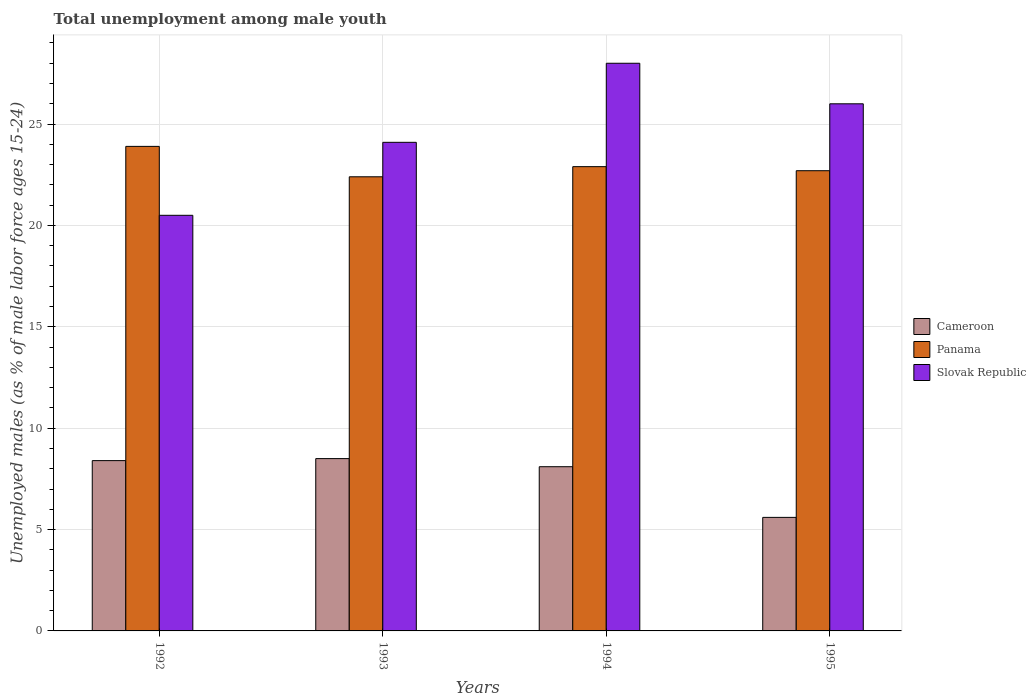How many different coloured bars are there?
Give a very brief answer. 3. How many groups of bars are there?
Give a very brief answer. 4. Are the number of bars per tick equal to the number of legend labels?
Offer a terse response. Yes. What is the label of the 1st group of bars from the left?
Give a very brief answer. 1992. What is the percentage of unemployed males in in Slovak Republic in 1992?
Ensure brevity in your answer.  20.5. Across all years, what is the maximum percentage of unemployed males in in Cameroon?
Provide a succinct answer. 8.5. Across all years, what is the minimum percentage of unemployed males in in Slovak Republic?
Your answer should be compact. 20.5. In which year was the percentage of unemployed males in in Cameroon maximum?
Your response must be concise. 1993. In which year was the percentage of unemployed males in in Cameroon minimum?
Offer a very short reply. 1995. What is the total percentage of unemployed males in in Panama in the graph?
Your answer should be compact. 91.9. What is the difference between the percentage of unemployed males in in Cameroon in 1992 and that in 1993?
Provide a succinct answer. -0.1. What is the difference between the percentage of unemployed males in in Cameroon in 1994 and the percentage of unemployed males in in Panama in 1995?
Make the answer very short. -14.6. What is the average percentage of unemployed males in in Slovak Republic per year?
Ensure brevity in your answer.  24.65. In the year 1992, what is the difference between the percentage of unemployed males in in Panama and percentage of unemployed males in in Cameroon?
Ensure brevity in your answer.  15.5. What is the ratio of the percentage of unemployed males in in Panama in 1992 to that in 1995?
Make the answer very short. 1.05. Is the percentage of unemployed males in in Slovak Republic in 1992 less than that in 1993?
Keep it short and to the point. Yes. What is the difference between the highest and the second highest percentage of unemployed males in in Slovak Republic?
Offer a very short reply. 2. In how many years, is the percentage of unemployed males in in Panama greater than the average percentage of unemployed males in in Panama taken over all years?
Provide a succinct answer. 1. What does the 2nd bar from the left in 1995 represents?
Your answer should be very brief. Panama. What does the 2nd bar from the right in 1995 represents?
Keep it short and to the point. Panama. Are all the bars in the graph horizontal?
Make the answer very short. No. How many years are there in the graph?
Your response must be concise. 4. What is the difference between two consecutive major ticks on the Y-axis?
Your answer should be compact. 5. Are the values on the major ticks of Y-axis written in scientific E-notation?
Give a very brief answer. No. Does the graph contain any zero values?
Your answer should be very brief. No. Does the graph contain grids?
Your response must be concise. Yes. How many legend labels are there?
Provide a succinct answer. 3. What is the title of the graph?
Offer a very short reply. Total unemployment among male youth. What is the label or title of the Y-axis?
Your response must be concise. Unemployed males (as % of male labor force ages 15-24). What is the Unemployed males (as % of male labor force ages 15-24) in Cameroon in 1992?
Keep it short and to the point. 8.4. What is the Unemployed males (as % of male labor force ages 15-24) in Panama in 1992?
Offer a terse response. 23.9. What is the Unemployed males (as % of male labor force ages 15-24) of Cameroon in 1993?
Provide a succinct answer. 8.5. What is the Unemployed males (as % of male labor force ages 15-24) in Panama in 1993?
Ensure brevity in your answer.  22.4. What is the Unemployed males (as % of male labor force ages 15-24) in Slovak Republic in 1993?
Offer a very short reply. 24.1. What is the Unemployed males (as % of male labor force ages 15-24) of Cameroon in 1994?
Provide a succinct answer. 8.1. What is the Unemployed males (as % of male labor force ages 15-24) in Panama in 1994?
Make the answer very short. 22.9. What is the Unemployed males (as % of male labor force ages 15-24) of Slovak Republic in 1994?
Your response must be concise. 28. What is the Unemployed males (as % of male labor force ages 15-24) in Cameroon in 1995?
Your answer should be very brief. 5.6. What is the Unemployed males (as % of male labor force ages 15-24) in Panama in 1995?
Provide a short and direct response. 22.7. What is the Unemployed males (as % of male labor force ages 15-24) in Slovak Republic in 1995?
Offer a very short reply. 26. Across all years, what is the maximum Unemployed males (as % of male labor force ages 15-24) in Panama?
Keep it short and to the point. 23.9. Across all years, what is the maximum Unemployed males (as % of male labor force ages 15-24) in Slovak Republic?
Your response must be concise. 28. Across all years, what is the minimum Unemployed males (as % of male labor force ages 15-24) of Cameroon?
Make the answer very short. 5.6. Across all years, what is the minimum Unemployed males (as % of male labor force ages 15-24) of Panama?
Your answer should be very brief. 22.4. Across all years, what is the minimum Unemployed males (as % of male labor force ages 15-24) in Slovak Republic?
Provide a succinct answer. 20.5. What is the total Unemployed males (as % of male labor force ages 15-24) of Cameroon in the graph?
Make the answer very short. 30.6. What is the total Unemployed males (as % of male labor force ages 15-24) of Panama in the graph?
Offer a terse response. 91.9. What is the total Unemployed males (as % of male labor force ages 15-24) in Slovak Republic in the graph?
Keep it short and to the point. 98.6. What is the difference between the Unemployed males (as % of male labor force ages 15-24) of Cameroon in 1992 and that in 1993?
Offer a terse response. -0.1. What is the difference between the Unemployed males (as % of male labor force ages 15-24) in Panama in 1992 and that in 1993?
Provide a short and direct response. 1.5. What is the difference between the Unemployed males (as % of male labor force ages 15-24) of Cameroon in 1992 and that in 1994?
Keep it short and to the point. 0.3. What is the difference between the Unemployed males (as % of male labor force ages 15-24) in Slovak Republic in 1992 and that in 1994?
Your answer should be compact. -7.5. What is the difference between the Unemployed males (as % of male labor force ages 15-24) in Cameroon in 1992 and that in 1995?
Your answer should be compact. 2.8. What is the difference between the Unemployed males (as % of male labor force ages 15-24) in Panama in 1992 and that in 1995?
Provide a succinct answer. 1.2. What is the difference between the Unemployed males (as % of male labor force ages 15-24) in Slovak Republic in 1992 and that in 1995?
Give a very brief answer. -5.5. What is the difference between the Unemployed males (as % of male labor force ages 15-24) in Cameroon in 1993 and that in 1994?
Ensure brevity in your answer.  0.4. What is the difference between the Unemployed males (as % of male labor force ages 15-24) in Cameroon in 1993 and that in 1995?
Keep it short and to the point. 2.9. What is the difference between the Unemployed males (as % of male labor force ages 15-24) in Slovak Republic in 1993 and that in 1995?
Give a very brief answer. -1.9. What is the difference between the Unemployed males (as % of male labor force ages 15-24) of Panama in 1994 and that in 1995?
Make the answer very short. 0.2. What is the difference between the Unemployed males (as % of male labor force ages 15-24) in Slovak Republic in 1994 and that in 1995?
Keep it short and to the point. 2. What is the difference between the Unemployed males (as % of male labor force ages 15-24) of Cameroon in 1992 and the Unemployed males (as % of male labor force ages 15-24) of Panama in 1993?
Your answer should be compact. -14. What is the difference between the Unemployed males (as % of male labor force ages 15-24) of Cameroon in 1992 and the Unemployed males (as % of male labor force ages 15-24) of Slovak Republic in 1993?
Make the answer very short. -15.7. What is the difference between the Unemployed males (as % of male labor force ages 15-24) in Panama in 1992 and the Unemployed males (as % of male labor force ages 15-24) in Slovak Republic in 1993?
Your response must be concise. -0.2. What is the difference between the Unemployed males (as % of male labor force ages 15-24) in Cameroon in 1992 and the Unemployed males (as % of male labor force ages 15-24) in Panama in 1994?
Your response must be concise. -14.5. What is the difference between the Unemployed males (as % of male labor force ages 15-24) in Cameroon in 1992 and the Unemployed males (as % of male labor force ages 15-24) in Slovak Republic in 1994?
Offer a terse response. -19.6. What is the difference between the Unemployed males (as % of male labor force ages 15-24) in Cameroon in 1992 and the Unemployed males (as % of male labor force ages 15-24) in Panama in 1995?
Ensure brevity in your answer.  -14.3. What is the difference between the Unemployed males (as % of male labor force ages 15-24) in Cameroon in 1992 and the Unemployed males (as % of male labor force ages 15-24) in Slovak Republic in 1995?
Your answer should be very brief. -17.6. What is the difference between the Unemployed males (as % of male labor force ages 15-24) in Cameroon in 1993 and the Unemployed males (as % of male labor force ages 15-24) in Panama in 1994?
Provide a succinct answer. -14.4. What is the difference between the Unemployed males (as % of male labor force ages 15-24) in Cameroon in 1993 and the Unemployed males (as % of male labor force ages 15-24) in Slovak Republic in 1994?
Keep it short and to the point. -19.5. What is the difference between the Unemployed males (as % of male labor force ages 15-24) in Panama in 1993 and the Unemployed males (as % of male labor force ages 15-24) in Slovak Republic in 1994?
Your answer should be very brief. -5.6. What is the difference between the Unemployed males (as % of male labor force ages 15-24) of Cameroon in 1993 and the Unemployed males (as % of male labor force ages 15-24) of Slovak Republic in 1995?
Offer a very short reply. -17.5. What is the difference between the Unemployed males (as % of male labor force ages 15-24) of Panama in 1993 and the Unemployed males (as % of male labor force ages 15-24) of Slovak Republic in 1995?
Provide a short and direct response. -3.6. What is the difference between the Unemployed males (as % of male labor force ages 15-24) of Cameroon in 1994 and the Unemployed males (as % of male labor force ages 15-24) of Panama in 1995?
Make the answer very short. -14.6. What is the difference between the Unemployed males (as % of male labor force ages 15-24) of Cameroon in 1994 and the Unemployed males (as % of male labor force ages 15-24) of Slovak Republic in 1995?
Offer a terse response. -17.9. What is the average Unemployed males (as % of male labor force ages 15-24) of Cameroon per year?
Offer a terse response. 7.65. What is the average Unemployed males (as % of male labor force ages 15-24) in Panama per year?
Make the answer very short. 22.98. What is the average Unemployed males (as % of male labor force ages 15-24) of Slovak Republic per year?
Keep it short and to the point. 24.65. In the year 1992, what is the difference between the Unemployed males (as % of male labor force ages 15-24) in Cameroon and Unemployed males (as % of male labor force ages 15-24) in Panama?
Provide a succinct answer. -15.5. In the year 1993, what is the difference between the Unemployed males (as % of male labor force ages 15-24) of Cameroon and Unemployed males (as % of male labor force ages 15-24) of Slovak Republic?
Keep it short and to the point. -15.6. In the year 1993, what is the difference between the Unemployed males (as % of male labor force ages 15-24) of Panama and Unemployed males (as % of male labor force ages 15-24) of Slovak Republic?
Your response must be concise. -1.7. In the year 1994, what is the difference between the Unemployed males (as % of male labor force ages 15-24) of Cameroon and Unemployed males (as % of male labor force ages 15-24) of Panama?
Offer a terse response. -14.8. In the year 1994, what is the difference between the Unemployed males (as % of male labor force ages 15-24) in Cameroon and Unemployed males (as % of male labor force ages 15-24) in Slovak Republic?
Your answer should be compact. -19.9. In the year 1995, what is the difference between the Unemployed males (as % of male labor force ages 15-24) of Cameroon and Unemployed males (as % of male labor force ages 15-24) of Panama?
Offer a very short reply. -17.1. In the year 1995, what is the difference between the Unemployed males (as % of male labor force ages 15-24) in Cameroon and Unemployed males (as % of male labor force ages 15-24) in Slovak Republic?
Provide a succinct answer. -20.4. What is the ratio of the Unemployed males (as % of male labor force ages 15-24) of Cameroon in 1992 to that in 1993?
Give a very brief answer. 0.99. What is the ratio of the Unemployed males (as % of male labor force ages 15-24) in Panama in 1992 to that in 1993?
Your response must be concise. 1.07. What is the ratio of the Unemployed males (as % of male labor force ages 15-24) in Slovak Republic in 1992 to that in 1993?
Your answer should be compact. 0.85. What is the ratio of the Unemployed males (as % of male labor force ages 15-24) of Cameroon in 1992 to that in 1994?
Offer a very short reply. 1.04. What is the ratio of the Unemployed males (as % of male labor force ages 15-24) in Panama in 1992 to that in 1994?
Make the answer very short. 1.04. What is the ratio of the Unemployed males (as % of male labor force ages 15-24) in Slovak Republic in 1992 to that in 1994?
Ensure brevity in your answer.  0.73. What is the ratio of the Unemployed males (as % of male labor force ages 15-24) in Panama in 1992 to that in 1995?
Provide a succinct answer. 1.05. What is the ratio of the Unemployed males (as % of male labor force ages 15-24) in Slovak Republic in 1992 to that in 1995?
Provide a short and direct response. 0.79. What is the ratio of the Unemployed males (as % of male labor force ages 15-24) of Cameroon in 1993 to that in 1994?
Make the answer very short. 1.05. What is the ratio of the Unemployed males (as % of male labor force ages 15-24) in Panama in 1993 to that in 1994?
Your answer should be very brief. 0.98. What is the ratio of the Unemployed males (as % of male labor force ages 15-24) of Slovak Republic in 1993 to that in 1994?
Keep it short and to the point. 0.86. What is the ratio of the Unemployed males (as % of male labor force ages 15-24) of Cameroon in 1993 to that in 1995?
Your answer should be very brief. 1.52. What is the ratio of the Unemployed males (as % of male labor force ages 15-24) of Slovak Republic in 1993 to that in 1995?
Keep it short and to the point. 0.93. What is the ratio of the Unemployed males (as % of male labor force ages 15-24) of Cameroon in 1994 to that in 1995?
Keep it short and to the point. 1.45. What is the ratio of the Unemployed males (as % of male labor force ages 15-24) in Panama in 1994 to that in 1995?
Your answer should be compact. 1.01. 